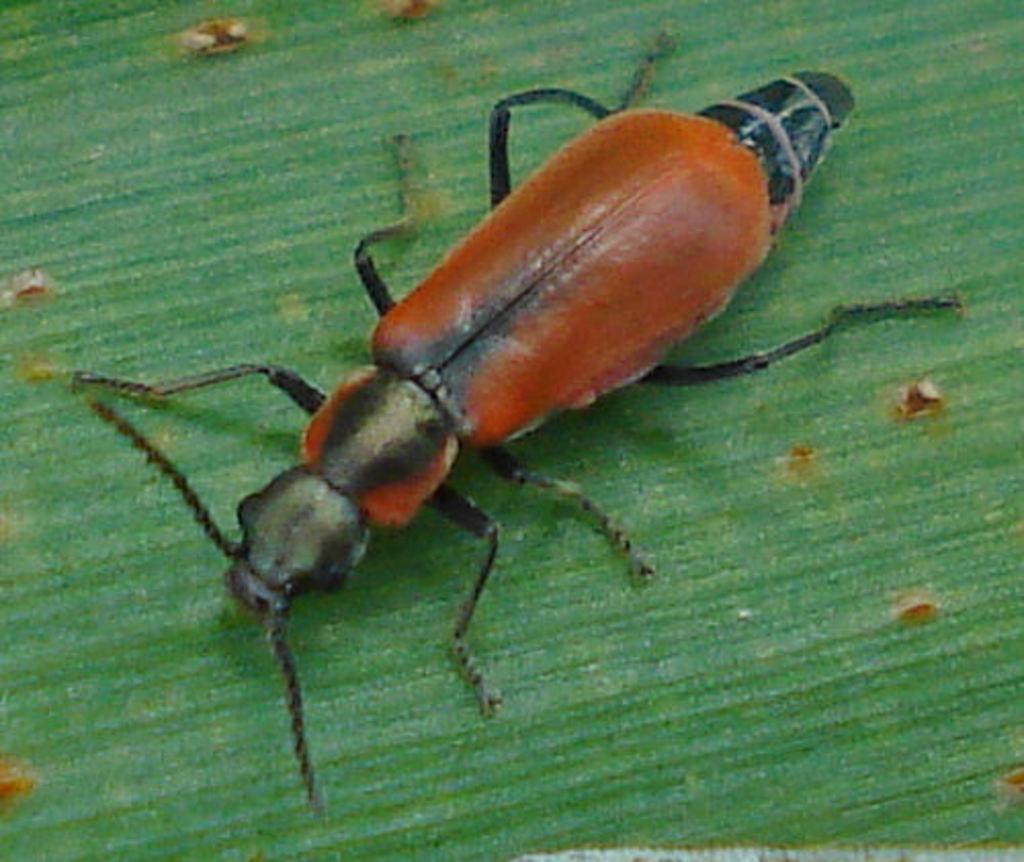Please provide a concise description of this image. In this image we can see an insect on the floor. 